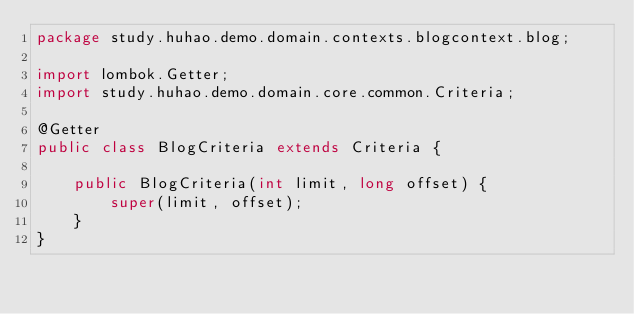Convert code to text. <code><loc_0><loc_0><loc_500><loc_500><_Java_>package study.huhao.demo.domain.contexts.blogcontext.blog;

import lombok.Getter;
import study.huhao.demo.domain.core.common.Criteria;

@Getter
public class BlogCriteria extends Criteria {

    public BlogCriteria(int limit, long offset) {
        super(limit, offset);
    }
}
</code> 